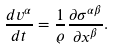<formula> <loc_0><loc_0><loc_500><loc_500>\frac { d v ^ { \alpha } } { d t } = \frac { 1 } { \varrho } \frac { \partial \sigma ^ { \alpha \beta } } { \partial x ^ { \beta } } .</formula> 